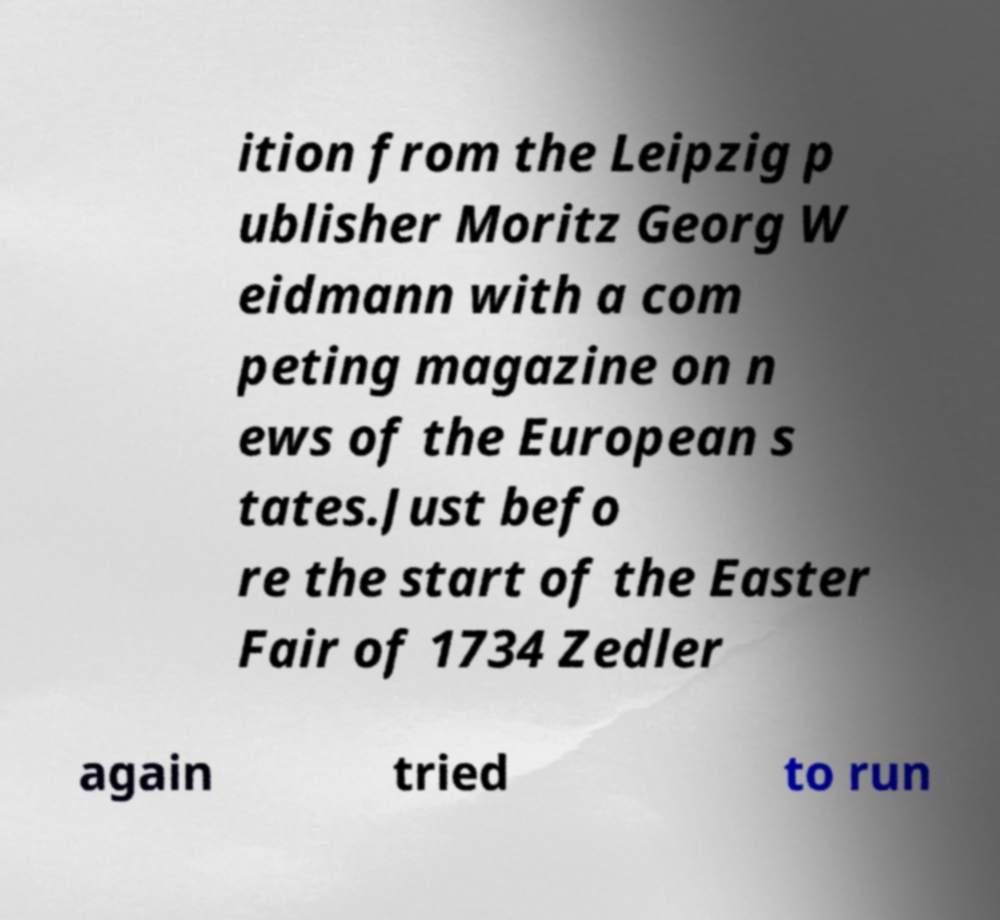Please identify and transcribe the text found in this image. ition from the Leipzig p ublisher Moritz Georg W eidmann with a com peting magazine on n ews of the European s tates.Just befo re the start of the Easter Fair of 1734 Zedler again tried to run 